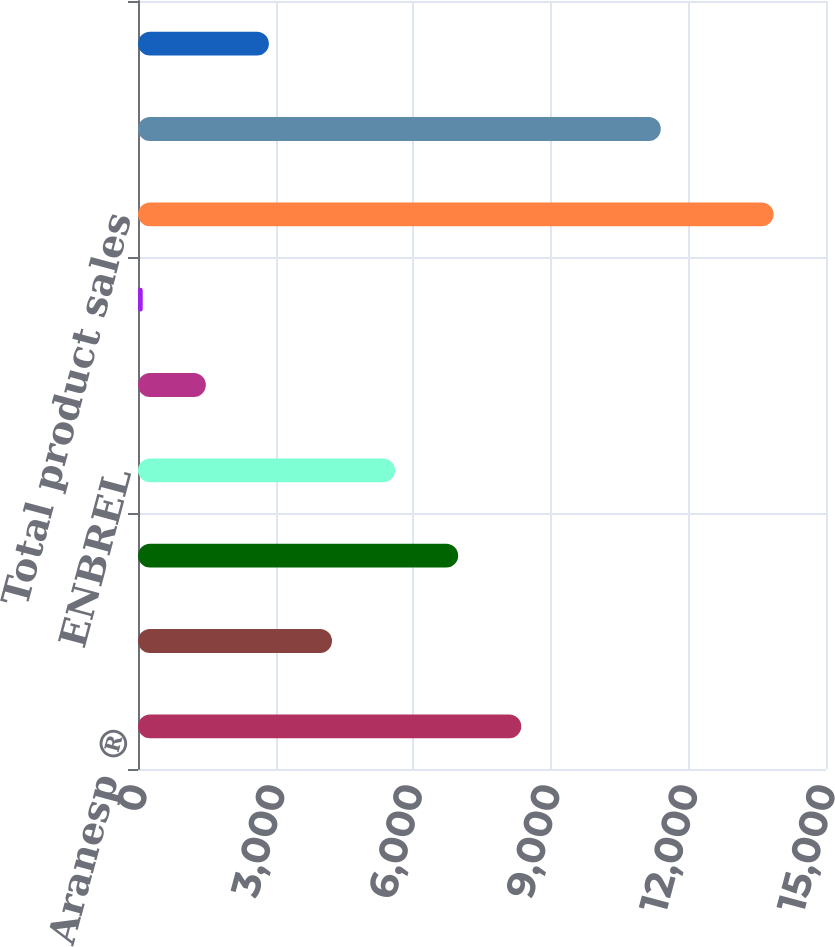Convert chart. <chart><loc_0><loc_0><loc_500><loc_500><bar_chart><fcel>Aranesp ®<fcel>EPOGEN ®<fcel>Neulasta^®/NEUPOGEN ®<fcel>ENBREL<fcel>Sensipar ®<fcel>Other<fcel>Total product sales<fcel>Total US<fcel>Total International<nl><fcel>8356<fcel>4229.5<fcel>6980.5<fcel>5605<fcel>1478.5<fcel>103<fcel>13858<fcel>11397<fcel>2854<nl></chart> 